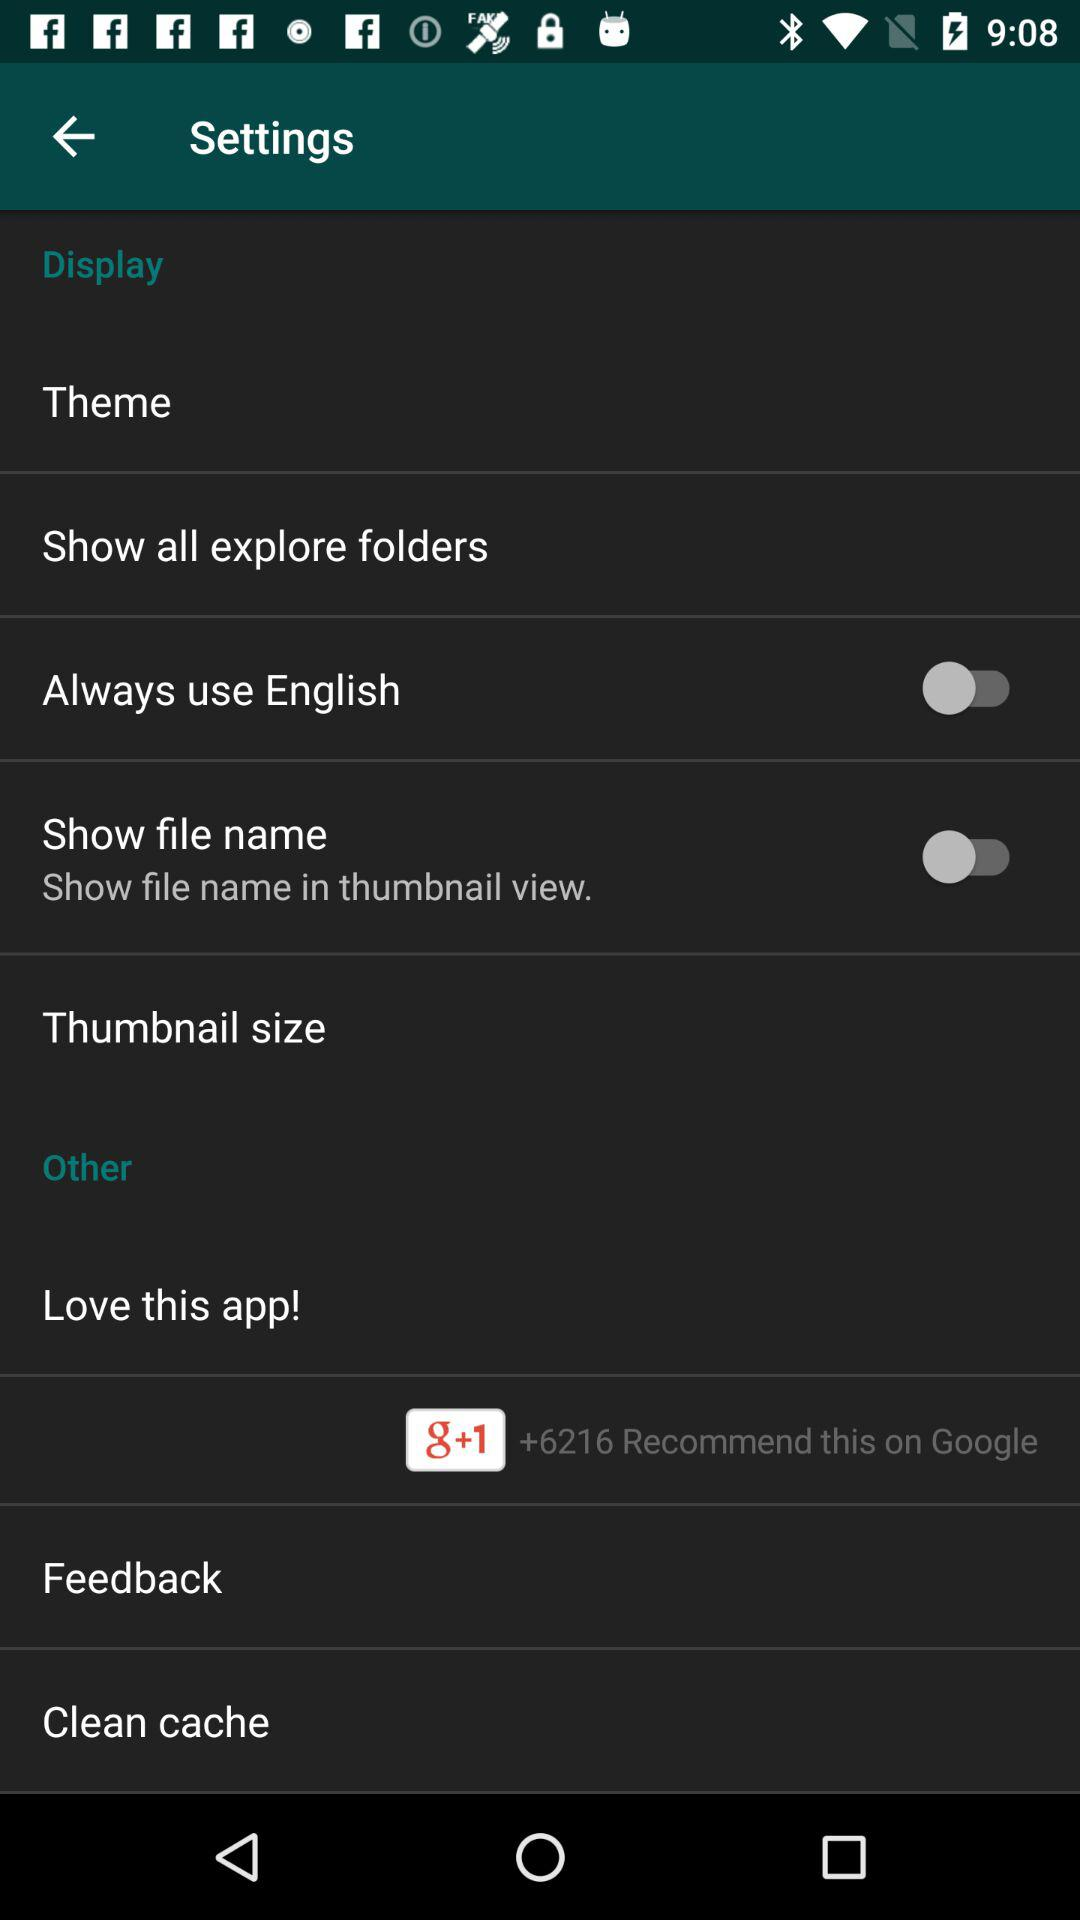How many users have recommended the app on Google? There are 6216 users who have recommended the app on Google. 